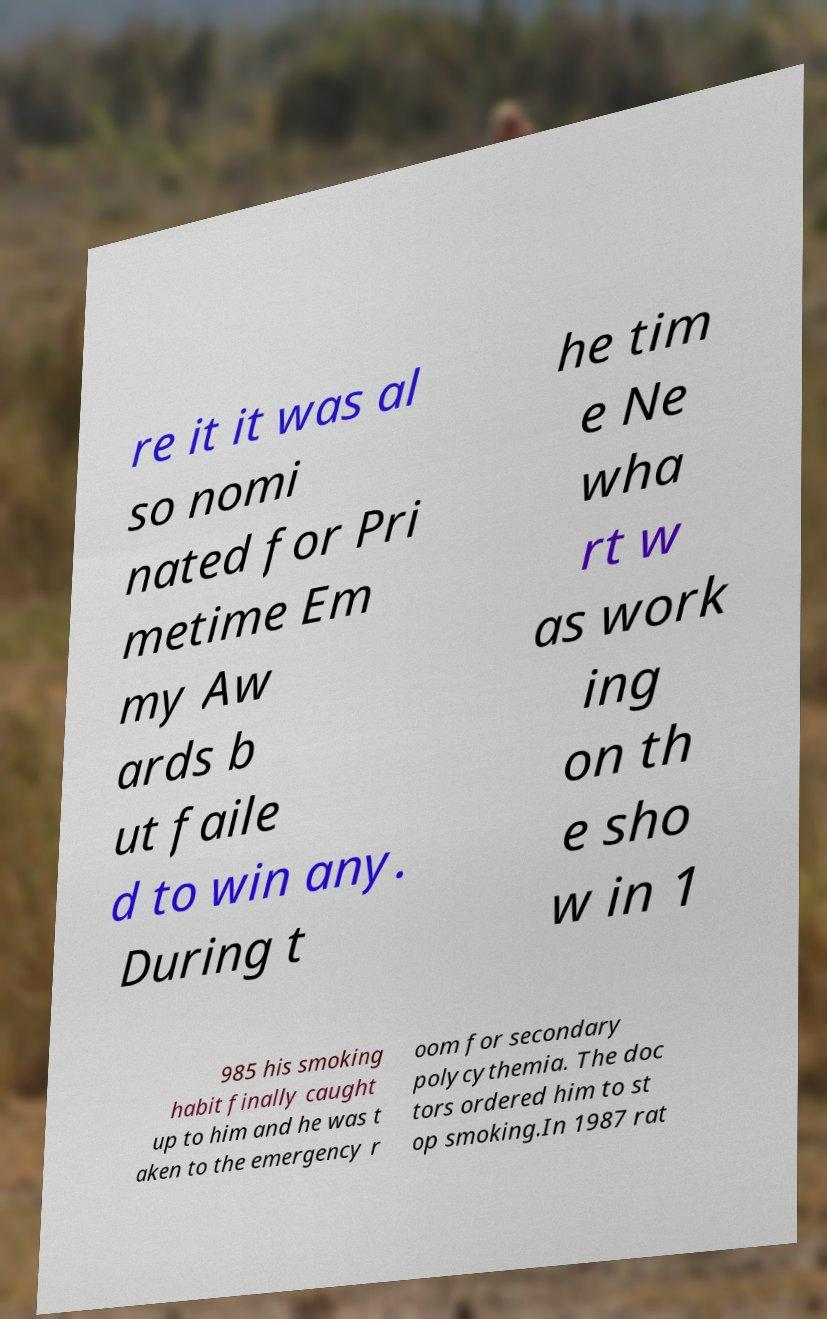Could you extract and type out the text from this image? re it it was al so nomi nated for Pri metime Em my Aw ards b ut faile d to win any. During t he tim e Ne wha rt w as work ing on th e sho w in 1 985 his smoking habit finally caught up to him and he was t aken to the emergency r oom for secondary polycythemia. The doc tors ordered him to st op smoking.In 1987 rat 